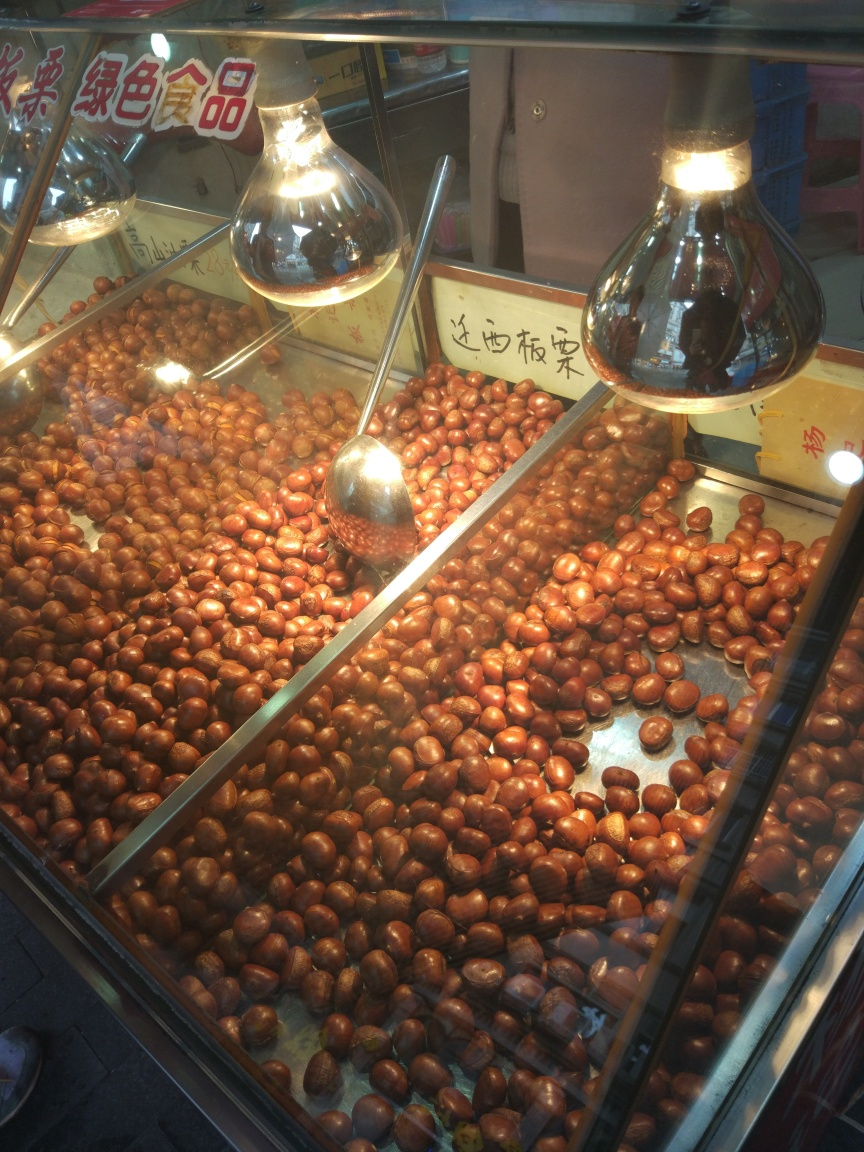Can you describe the setting where this photo was taken? The photo appears to be taken at a street food vendor or market stall, where the chestnuts are kept warm under large light bulbs. Such displays are commonly found in bustling marketplaces, inviting passersby to make a purchase. Is there anything unusual or particularly interesting about this setup? The use of oversized light bulbs is a distinct feature that not only highlights the chestnuts but also adds to the visual appeal of the stall. Furthermore, the reflection on the glass showcases a lively environment, suggesting this stall is part of a busy market. 